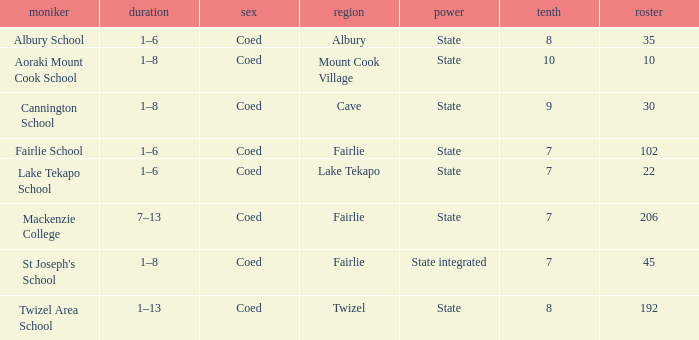What is the total Decile that has a state authority, fairlie area and roll smarter than 206? 1.0. Can you give me this table as a dict? {'header': ['moniker', 'duration', 'sex', 'region', 'power', 'tenth', 'roster'], 'rows': [['Albury School', '1–6', 'Coed', 'Albury', 'State', '8', '35'], ['Aoraki Mount Cook School', '1–8', 'Coed', 'Mount Cook Village', 'State', '10', '10'], ['Cannington School', '1–8', 'Coed', 'Cave', 'State', '9', '30'], ['Fairlie School', '1–6', 'Coed', 'Fairlie', 'State', '7', '102'], ['Lake Tekapo School', '1–6', 'Coed', 'Lake Tekapo', 'State', '7', '22'], ['Mackenzie College', '7–13', 'Coed', 'Fairlie', 'State', '7', '206'], ["St Joseph's School", '1–8', 'Coed', 'Fairlie', 'State integrated', '7', '45'], ['Twizel Area School', '1–13', 'Coed', 'Twizel', 'State', '8', '192']]} 